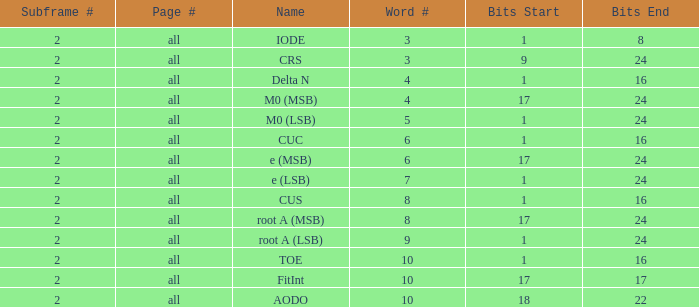What is the total count of subframes with 18-22 bits? 2.0. Help me parse the entirety of this table. {'header': ['Subframe #', 'Page #', 'Name', 'Word #', 'Bits Start', 'Bits End'], 'rows': [['2', 'all', 'IODE', '3', '1', '8'], ['2', 'all', 'CRS', '3', '9', '24'], ['2', 'all', 'Delta N', '4', '1', '16'], ['2', 'all', 'M0 (MSB)', '4', '17', '24'], ['2', 'all', 'M0 (LSB)', '5', '1', '24'], ['2', 'all', 'CUC', '6', '1', '16'], ['2', 'all', 'e (MSB)', '6', '17', '24'], ['2', 'all', 'e (LSB)', '7', '1', '24'], ['2', 'all', 'CUS', '8', '1', '16'], ['2', 'all', 'root A (MSB)', '8', '17', '24'], ['2', 'all', 'root A (LSB)', '9', '1', '24'], ['2', 'all', 'TOE', '10', '1', '16'], ['2', 'all', 'FitInt', '10', '17', '17'], ['2', 'all', 'AODO', '10', '18', '22']]} 